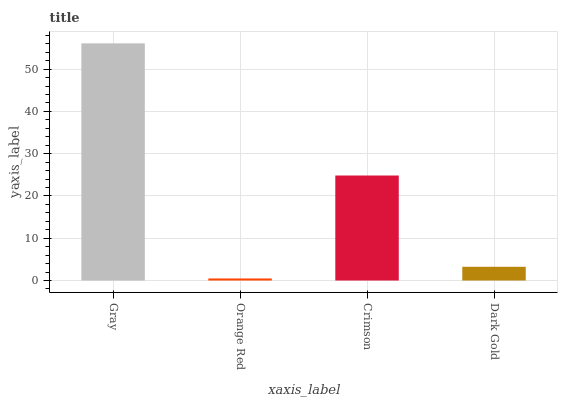Is Orange Red the minimum?
Answer yes or no. Yes. Is Gray the maximum?
Answer yes or no. Yes. Is Crimson the minimum?
Answer yes or no. No. Is Crimson the maximum?
Answer yes or no. No. Is Crimson greater than Orange Red?
Answer yes or no. Yes. Is Orange Red less than Crimson?
Answer yes or no. Yes. Is Orange Red greater than Crimson?
Answer yes or no. No. Is Crimson less than Orange Red?
Answer yes or no. No. Is Crimson the high median?
Answer yes or no. Yes. Is Dark Gold the low median?
Answer yes or no. Yes. Is Orange Red the high median?
Answer yes or no. No. Is Crimson the low median?
Answer yes or no. No. 